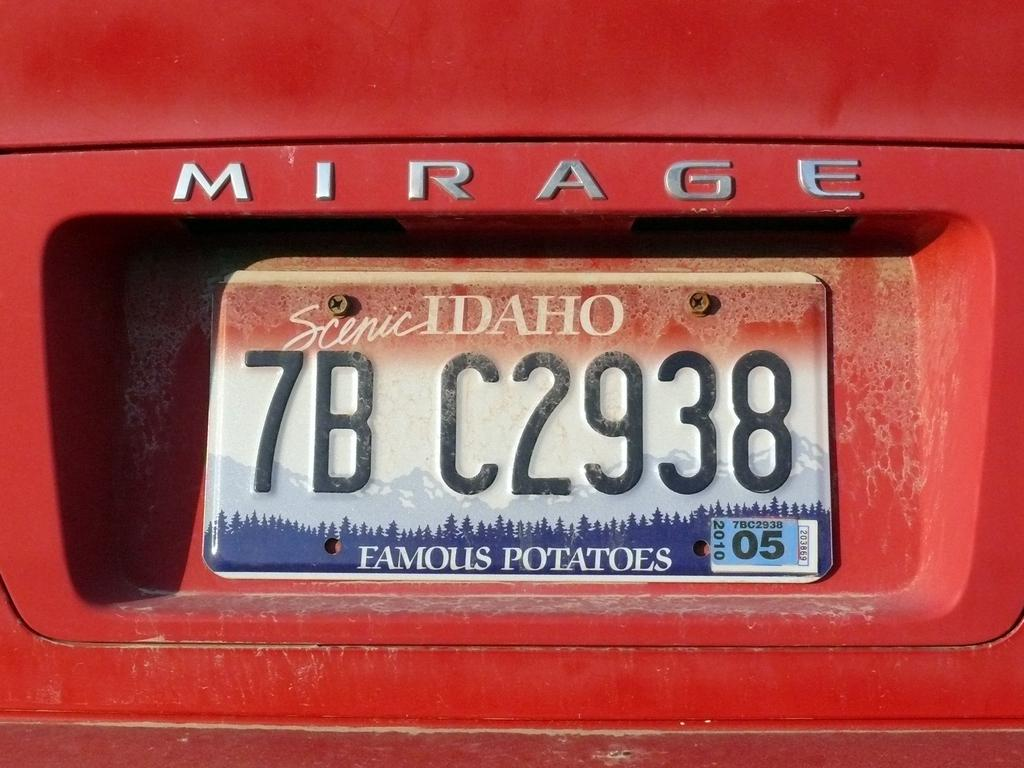<image>
Give a short and clear explanation of the subsequent image. The back of a red Mirage car with an Idaho license plate with the numbers 7BC2938 